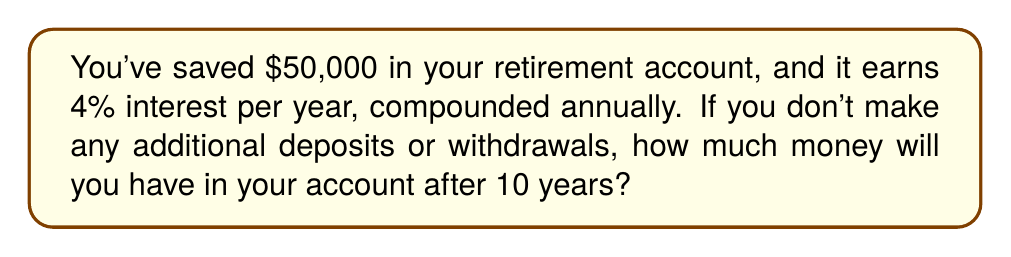Can you answer this question? Let's approach this step-by-step:

1. We'll use the compound interest formula:
   $$ A = P(1 + r)^n $$
   Where:
   $A$ is the final amount
   $P$ is the principal (initial investment)
   $r$ is the annual interest rate (in decimal form)
   $n$ is the number of years

2. We know:
   $P = \$50,000$
   $r = 4\% = 0.04$
   $n = 10$ years

3. Let's plug these values into our formula:
   $$ A = 50,000(1 + 0.04)^{10} $$

4. Now, let's calculate:
   $$ A = 50,000(1.04)^{10} $$
   $$ A = 50,000(1.4802) $$
   $$ A = 74,012.07 $$

5. Rounding to the nearest dollar:
   $$ A \approx \$74,012 $$

So, after 10 years, your $50,000 will grow to approximately $74,012.
Answer: $74,012 